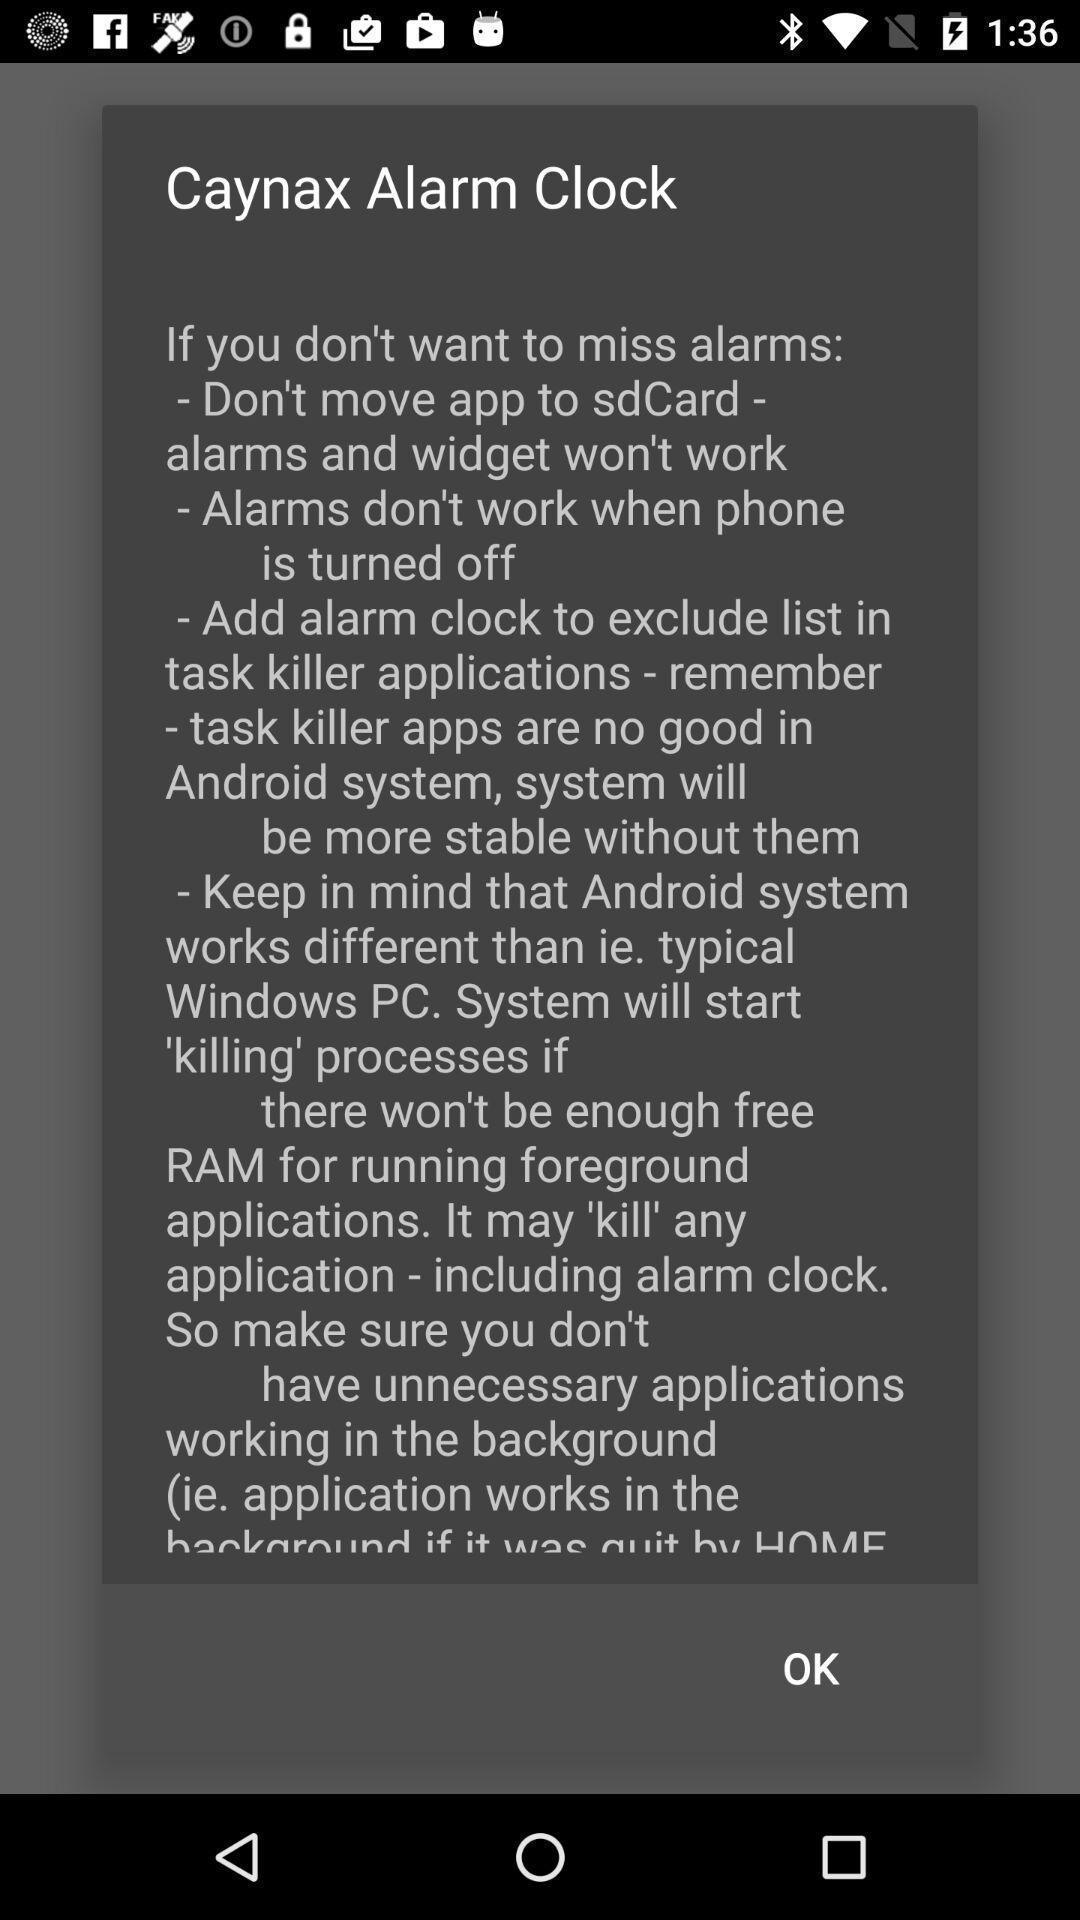Explain the elements present in this screenshot. Popup showing information of alarm clock. 